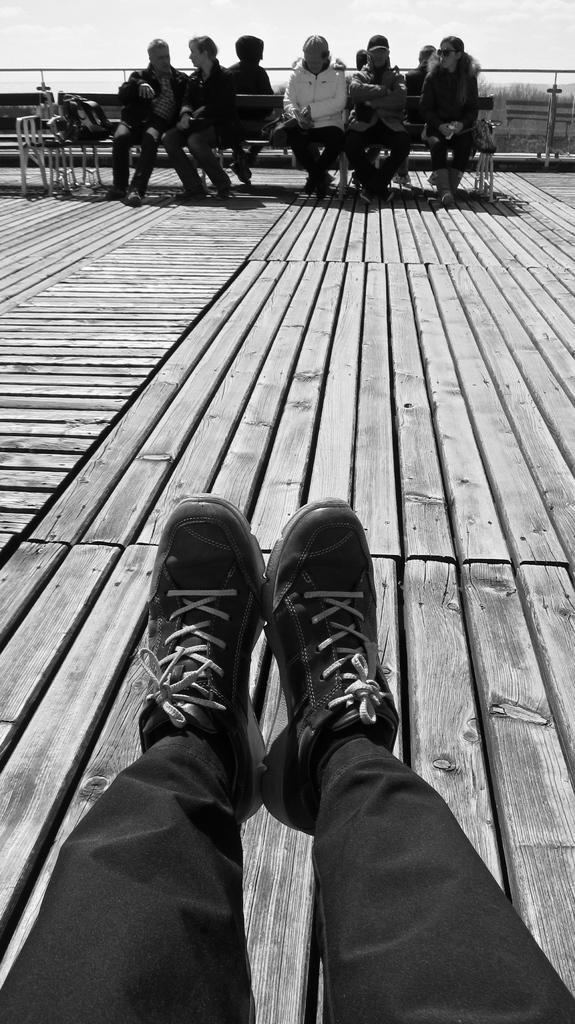In one or two sentences, can you explain what this image depicts? This is a black and white image. There are a few people. We can see some benches with objects. We can see the wooden surface and the fence. We can also see the sky. 